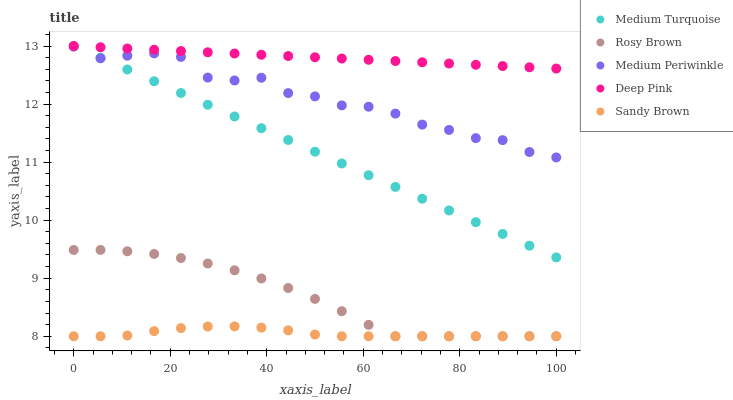Does Sandy Brown have the minimum area under the curve?
Answer yes or no. Yes. Does Deep Pink have the maximum area under the curve?
Answer yes or no. Yes. Does Rosy Brown have the minimum area under the curve?
Answer yes or no. No. Does Rosy Brown have the maximum area under the curve?
Answer yes or no. No. Is Medium Turquoise the smoothest?
Answer yes or no. Yes. Is Medium Periwinkle the roughest?
Answer yes or no. Yes. Is Rosy Brown the smoothest?
Answer yes or no. No. Is Rosy Brown the roughest?
Answer yes or no. No. Does Sandy Brown have the lowest value?
Answer yes or no. Yes. Does Medium Periwinkle have the lowest value?
Answer yes or no. No. Does Deep Pink have the highest value?
Answer yes or no. Yes. Does Rosy Brown have the highest value?
Answer yes or no. No. Is Medium Periwinkle less than Deep Pink?
Answer yes or no. Yes. Is Deep Pink greater than Rosy Brown?
Answer yes or no. Yes. Does Medium Turquoise intersect Deep Pink?
Answer yes or no. Yes. Is Medium Turquoise less than Deep Pink?
Answer yes or no. No. Is Medium Turquoise greater than Deep Pink?
Answer yes or no. No. Does Medium Periwinkle intersect Deep Pink?
Answer yes or no. No. 